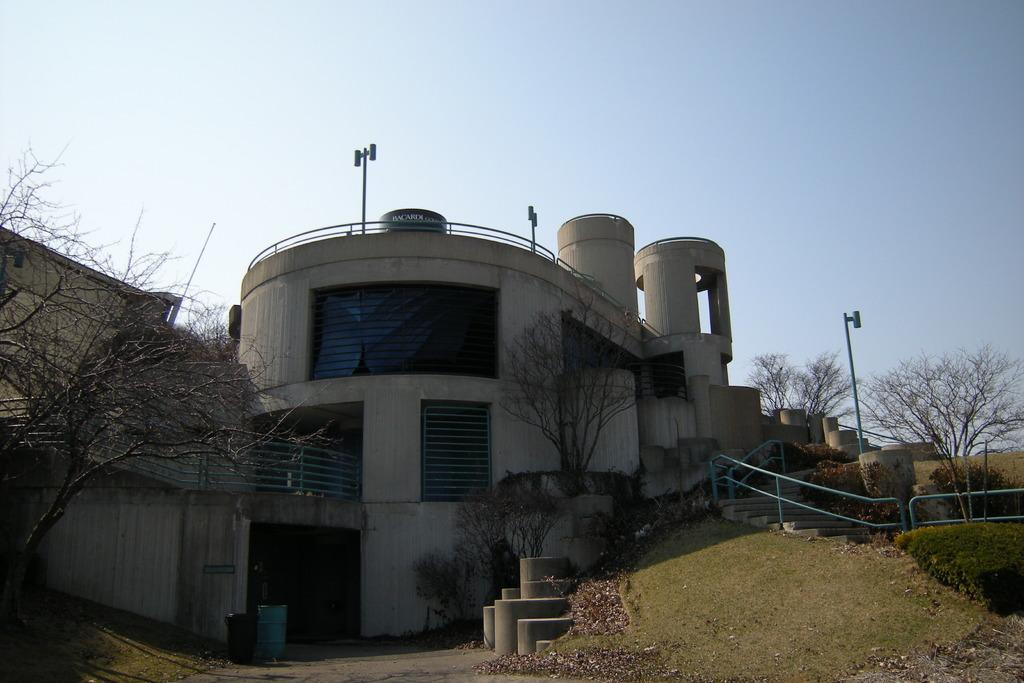What type of structure is present in the image? There is a building in the image. What natural elements can be seen in the image? There are trees, plants, and grass in the image. What objects are present for waste disposal? There are bins in the image. What vertical structures are present in the image? There are poles in the image. What can be seen in the background of the image? The sky is visible in the background of the image. What type of rice is being cooked in the image? There is no rice present in the image; it features a building, trees, plants, grass, bins, poles, and the sky. 